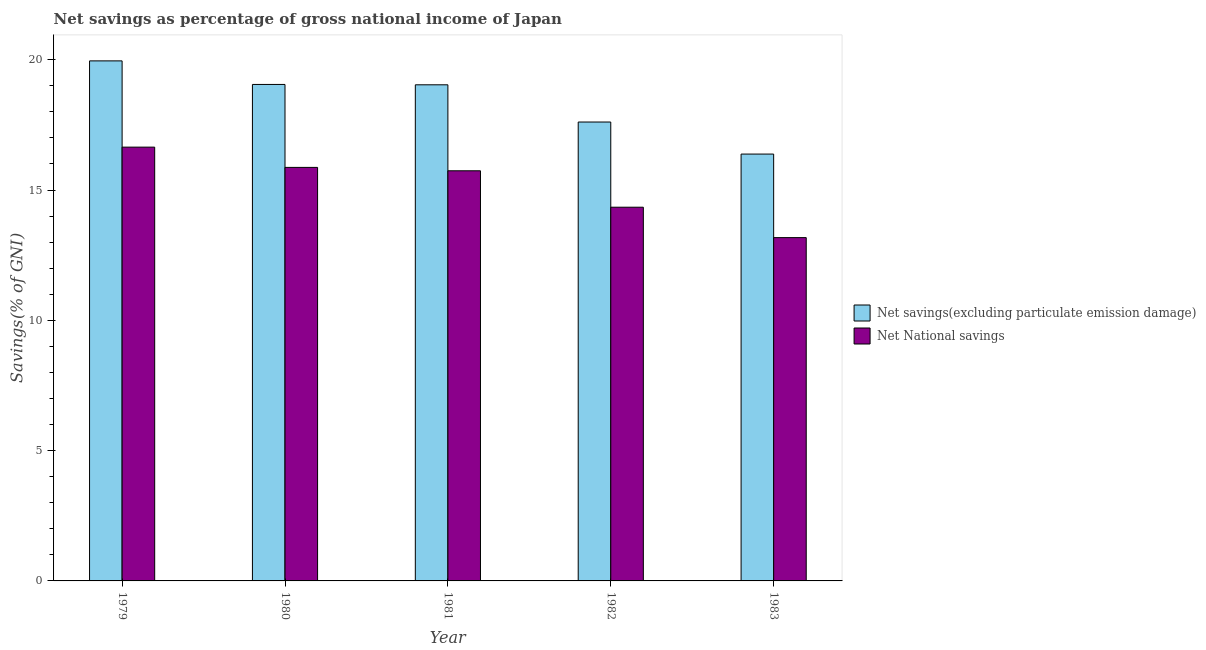How many different coloured bars are there?
Ensure brevity in your answer.  2. Are the number of bars per tick equal to the number of legend labels?
Your answer should be compact. Yes. Are the number of bars on each tick of the X-axis equal?
Offer a very short reply. Yes. How many bars are there on the 4th tick from the right?
Offer a very short reply. 2. What is the net national savings in 1981?
Keep it short and to the point. 15.74. Across all years, what is the maximum net savings(excluding particulate emission damage)?
Offer a terse response. 19.96. Across all years, what is the minimum net savings(excluding particulate emission damage)?
Provide a short and direct response. 16.38. In which year was the net national savings maximum?
Ensure brevity in your answer.  1979. In which year was the net national savings minimum?
Make the answer very short. 1983. What is the total net savings(excluding particulate emission damage) in the graph?
Provide a succinct answer. 92.04. What is the difference between the net savings(excluding particulate emission damage) in 1979 and that in 1983?
Your answer should be compact. 3.58. What is the difference between the net savings(excluding particulate emission damage) in 1981 and the net national savings in 1982?
Offer a terse response. 1.43. What is the average net savings(excluding particulate emission damage) per year?
Your response must be concise. 18.41. What is the ratio of the net national savings in 1981 to that in 1983?
Give a very brief answer. 1.19. What is the difference between the highest and the second highest net savings(excluding particulate emission damage)?
Your response must be concise. 0.9. What is the difference between the highest and the lowest net national savings?
Provide a succinct answer. 3.47. In how many years, is the net savings(excluding particulate emission damage) greater than the average net savings(excluding particulate emission damage) taken over all years?
Your answer should be compact. 3. Is the sum of the net savings(excluding particulate emission damage) in 1980 and 1981 greater than the maximum net national savings across all years?
Keep it short and to the point. Yes. What does the 1st bar from the left in 1982 represents?
Offer a terse response. Net savings(excluding particulate emission damage). What does the 1st bar from the right in 1981 represents?
Offer a terse response. Net National savings. How many bars are there?
Ensure brevity in your answer.  10. How many years are there in the graph?
Your answer should be compact. 5. Does the graph contain grids?
Provide a succinct answer. No. Where does the legend appear in the graph?
Provide a short and direct response. Center right. What is the title of the graph?
Provide a short and direct response. Net savings as percentage of gross national income of Japan. What is the label or title of the Y-axis?
Ensure brevity in your answer.  Savings(% of GNI). What is the Savings(% of GNI) in Net savings(excluding particulate emission damage) in 1979?
Offer a terse response. 19.96. What is the Savings(% of GNI) of Net National savings in 1979?
Offer a very short reply. 16.65. What is the Savings(% of GNI) in Net savings(excluding particulate emission damage) in 1980?
Your answer should be compact. 19.05. What is the Savings(% of GNI) in Net National savings in 1980?
Provide a succinct answer. 15.87. What is the Savings(% of GNI) of Net savings(excluding particulate emission damage) in 1981?
Offer a very short reply. 19.04. What is the Savings(% of GNI) in Net National savings in 1981?
Make the answer very short. 15.74. What is the Savings(% of GNI) in Net savings(excluding particulate emission damage) in 1982?
Your answer should be very brief. 17.61. What is the Savings(% of GNI) of Net National savings in 1982?
Make the answer very short. 14.34. What is the Savings(% of GNI) in Net savings(excluding particulate emission damage) in 1983?
Your response must be concise. 16.38. What is the Savings(% of GNI) in Net National savings in 1983?
Your response must be concise. 13.17. Across all years, what is the maximum Savings(% of GNI) of Net savings(excluding particulate emission damage)?
Offer a very short reply. 19.96. Across all years, what is the maximum Savings(% of GNI) of Net National savings?
Make the answer very short. 16.65. Across all years, what is the minimum Savings(% of GNI) of Net savings(excluding particulate emission damage)?
Provide a succinct answer. 16.38. Across all years, what is the minimum Savings(% of GNI) of Net National savings?
Provide a succinct answer. 13.17. What is the total Savings(% of GNI) in Net savings(excluding particulate emission damage) in the graph?
Your answer should be compact. 92.04. What is the total Savings(% of GNI) of Net National savings in the graph?
Ensure brevity in your answer.  75.77. What is the difference between the Savings(% of GNI) in Net savings(excluding particulate emission damage) in 1979 and that in 1980?
Offer a terse response. 0.9. What is the difference between the Savings(% of GNI) in Net savings(excluding particulate emission damage) in 1979 and that in 1981?
Keep it short and to the point. 0.92. What is the difference between the Savings(% of GNI) of Net National savings in 1979 and that in 1981?
Provide a short and direct response. 0.91. What is the difference between the Savings(% of GNI) of Net savings(excluding particulate emission damage) in 1979 and that in 1982?
Offer a terse response. 2.35. What is the difference between the Savings(% of GNI) of Net National savings in 1979 and that in 1982?
Your response must be concise. 2.31. What is the difference between the Savings(% of GNI) of Net savings(excluding particulate emission damage) in 1979 and that in 1983?
Offer a terse response. 3.58. What is the difference between the Savings(% of GNI) of Net National savings in 1979 and that in 1983?
Your response must be concise. 3.47. What is the difference between the Savings(% of GNI) in Net savings(excluding particulate emission damage) in 1980 and that in 1981?
Your answer should be compact. 0.01. What is the difference between the Savings(% of GNI) of Net National savings in 1980 and that in 1981?
Ensure brevity in your answer.  0.13. What is the difference between the Savings(% of GNI) of Net savings(excluding particulate emission damage) in 1980 and that in 1982?
Offer a very short reply. 1.44. What is the difference between the Savings(% of GNI) of Net National savings in 1980 and that in 1982?
Offer a terse response. 1.53. What is the difference between the Savings(% of GNI) of Net savings(excluding particulate emission damage) in 1980 and that in 1983?
Make the answer very short. 2.67. What is the difference between the Savings(% of GNI) in Net National savings in 1980 and that in 1983?
Make the answer very short. 2.69. What is the difference between the Savings(% of GNI) in Net savings(excluding particulate emission damage) in 1981 and that in 1982?
Your answer should be very brief. 1.43. What is the difference between the Savings(% of GNI) of Net National savings in 1981 and that in 1982?
Your response must be concise. 1.4. What is the difference between the Savings(% of GNI) of Net savings(excluding particulate emission damage) in 1981 and that in 1983?
Provide a short and direct response. 2.66. What is the difference between the Savings(% of GNI) of Net National savings in 1981 and that in 1983?
Offer a very short reply. 2.56. What is the difference between the Savings(% of GNI) of Net savings(excluding particulate emission damage) in 1982 and that in 1983?
Your response must be concise. 1.23. What is the difference between the Savings(% of GNI) of Net National savings in 1982 and that in 1983?
Offer a very short reply. 1.17. What is the difference between the Savings(% of GNI) of Net savings(excluding particulate emission damage) in 1979 and the Savings(% of GNI) of Net National savings in 1980?
Your response must be concise. 4.09. What is the difference between the Savings(% of GNI) in Net savings(excluding particulate emission damage) in 1979 and the Savings(% of GNI) in Net National savings in 1981?
Provide a succinct answer. 4.22. What is the difference between the Savings(% of GNI) in Net savings(excluding particulate emission damage) in 1979 and the Savings(% of GNI) in Net National savings in 1982?
Your response must be concise. 5.62. What is the difference between the Savings(% of GNI) in Net savings(excluding particulate emission damage) in 1979 and the Savings(% of GNI) in Net National savings in 1983?
Your answer should be very brief. 6.78. What is the difference between the Savings(% of GNI) of Net savings(excluding particulate emission damage) in 1980 and the Savings(% of GNI) of Net National savings in 1981?
Ensure brevity in your answer.  3.31. What is the difference between the Savings(% of GNI) of Net savings(excluding particulate emission damage) in 1980 and the Savings(% of GNI) of Net National savings in 1982?
Keep it short and to the point. 4.71. What is the difference between the Savings(% of GNI) in Net savings(excluding particulate emission damage) in 1980 and the Savings(% of GNI) in Net National savings in 1983?
Keep it short and to the point. 5.88. What is the difference between the Savings(% of GNI) of Net savings(excluding particulate emission damage) in 1981 and the Savings(% of GNI) of Net National savings in 1982?
Make the answer very short. 4.7. What is the difference between the Savings(% of GNI) of Net savings(excluding particulate emission damage) in 1981 and the Savings(% of GNI) of Net National savings in 1983?
Offer a very short reply. 5.86. What is the difference between the Savings(% of GNI) of Net savings(excluding particulate emission damage) in 1982 and the Savings(% of GNI) of Net National savings in 1983?
Give a very brief answer. 4.44. What is the average Savings(% of GNI) in Net savings(excluding particulate emission damage) per year?
Give a very brief answer. 18.41. What is the average Savings(% of GNI) of Net National savings per year?
Make the answer very short. 15.15. In the year 1979, what is the difference between the Savings(% of GNI) of Net savings(excluding particulate emission damage) and Savings(% of GNI) of Net National savings?
Provide a succinct answer. 3.31. In the year 1980, what is the difference between the Savings(% of GNI) in Net savings(excluding particulate emission damage) and Savings(% of GNI) in Net National savings?
Ensure brevity in your answer.  3.18. In the year 1981, what is the difference between the Savings(% of GNI) of Net savings(excluding particulate emission damage) and Savings(% of GNI) of Net National savings?
Provide a short and direct response. 3.3. In the year 1982, what is the difference between the Savings(% of GNI) of Net savings(excluding particulate emission damage) and Savings(% of GNI) of Net National savings?
Make the answer very short. 3.27. In the year 1983, what is the difference between the Savings(% of GNI) of Net savings(excluding particulate emission damage) and Savings(% of GNI) of Net National savings?
Offer a terse response. 3.21. What is the ratio of the Savings(% of GNI) of Net savings(excluding particulate emission damage) in 1979 to that in 1980?
Provide a succinct answer. 1.05. What is the ratio of the Savings(% of GNI) in Net National savings in 1979 to that in 1980?
Offer a very short reply. 1.05. What is the ratio of the Savings(% of GNI) of Net savings(excluding particulate emission damage) in 1979 to that in 1981?
Offer a terse response. 1.05. What is the ratio of the Savings(% of GNI) of Net National savings in 1979 to that in 1981?
Provide a short and direct response. 1.06. What is the ratio of the Savings(% of GNI) of Net savings(excluding particulate emission damage) in 1979 to that in 1982?
Your answer should be compact. 1.13. What is the ratio of the Savings(% of GNI) of Net National savings in 1979 to that in 1982?
Offer a very short reply. 1.16. What is the ratio of the Savings(% of GNI) in Net savings(excluding particulate emission damage) in 1979 to that in 1983?
Keep it short and to the point. 1.22. What is the ratio of the Savings(% of GNI) of Net National savings in 1979 to that in 1983?
Keep it short and to the point. 1.26. What is the ratio of the Savings(% of GNI) in Net savings(excluding particulate emission damage) in 1980 to that in 1981?
Your answer should be very brief. 1. What is the ratio of the Savings(% of GNI) in Net National savings in 1980 to that in 1981?
Provide a short and direct response. 1.01. What is the ratio of the Savings(% of GNI) in Net savings(excluding particulate emission damage) in 1980 to that in 1982?
Your answer should be very brief. 1.08. What is the ratio of the Savings(% of GNI) in Net National savings in 1980 to that in 1982?
Offer a terse response. 1.11. What is the ratio of the Savings(% of GNI) of Net savings(excluding particulate emission damage) in 1980 to that in 1983?
Make the answer very short. 1.16. What is the ratio of the Savings(% of GNI) in Net National savings in 1980 to that in 1983?
Make the answer very short. 1.2. What is the ratio of the Savings(% of GNI) in Net savings(excluding particulate emission damage) in 1981 to that in 1982?
Ensure brevity in your answer.  1.08. What is the ratio of the Savings(% of GNI) of Net National savings in 1981 to that in 1982?
Your response must be concise. 1.1. What is the ratio of the Savings(% of GNI) in Net savings(excluding particulate emission damage) in 1981 to that in 1983?
Ensure brevity in your answer.  1.16. What is the ratio of the Savings(% of GNI) in Net National savings in 1981 to that in 1983?
Make the answer very short. 1.19. What is the ratio of the Savings(% of GNI) of Net savings(excluding particulate emission damage) in 1982 to that in 1983?
Your answer should be very brief. 1.08. What is the ratio of the Savings(% of GNI) in Net National savings in 1982 to that in 1983?
Your answer should be very brief. 1.09. What is the difference between the highest and the second highest Savings(% of GNI) in Net savings(excluding particulate emission damage)?
Provide a succinct answer. 0.9. What is the difference between the highest and the lowest Savings(% of GNI) of Net savings(excluding particulate emission damage)?
Keep it short and to the point. 3.58. What is the difference between the highest and the lowest Savings(% of GNI) of Net National savings?
Provide a short and direct response. 3.47. 